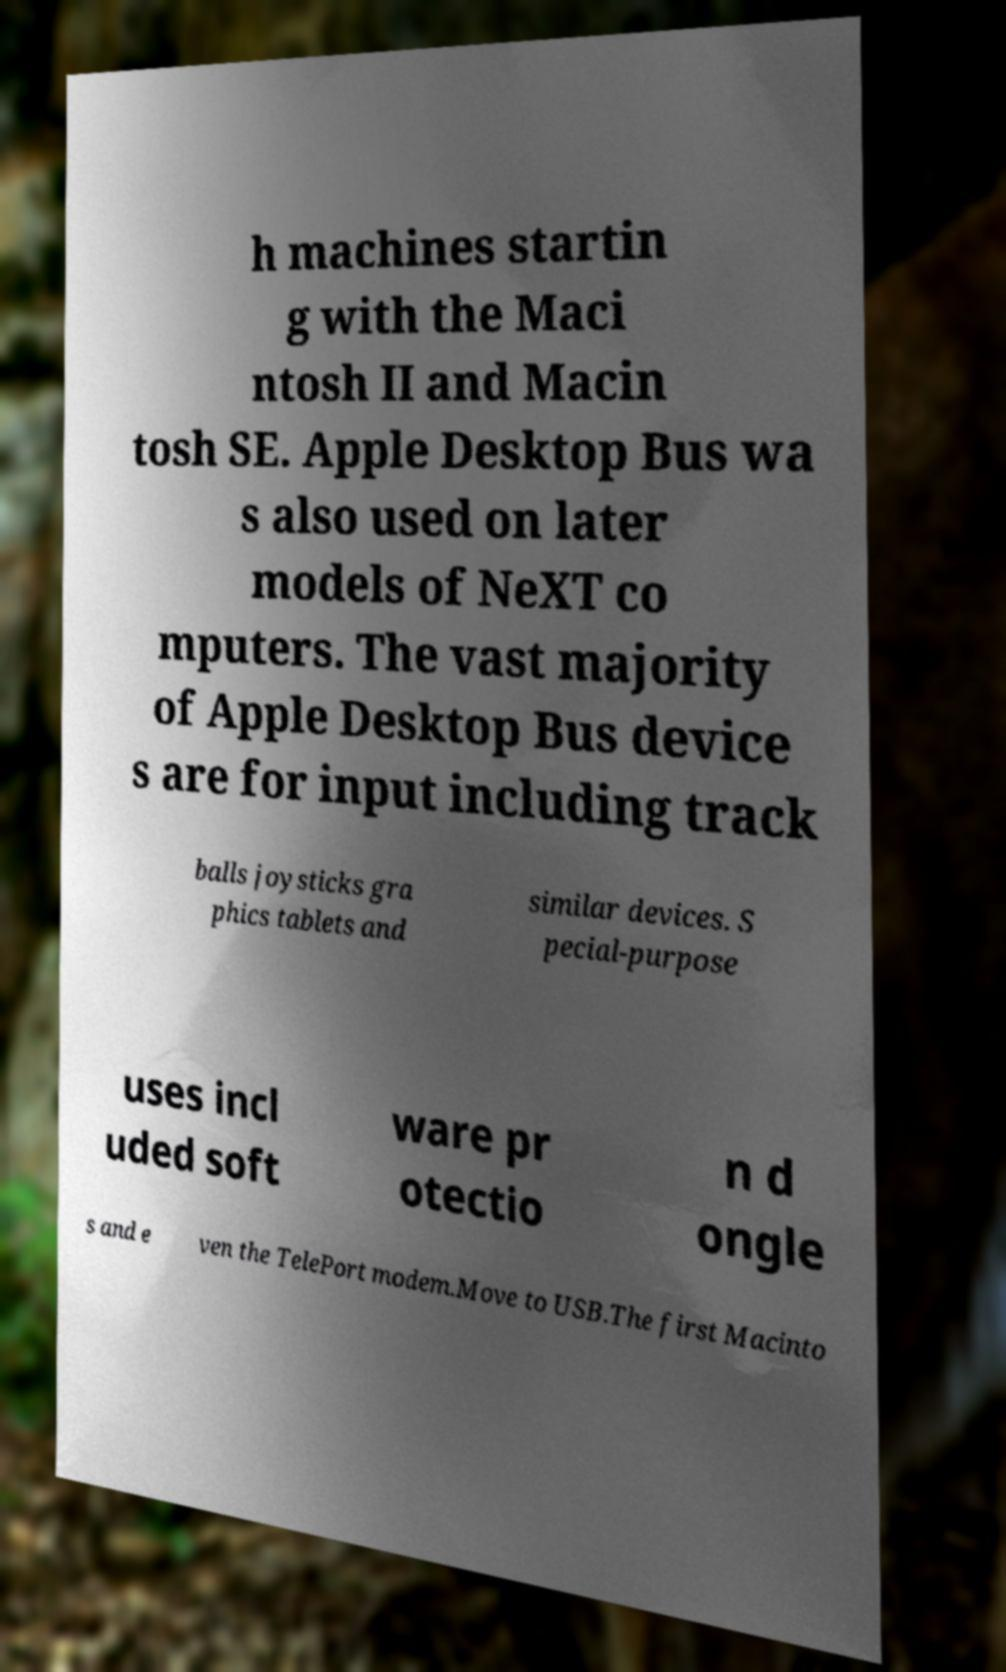Please read and relay the text visible in this image. What does it say? h machines startin g with the Maci ntosh II and Macin tosh SE. Apple Desktop Bus wa s also used on later models of NeXT co mputers. The vast majority of Apple Desktop Bus device s are for input including track balls joysticks gra phics tablets and similar devices. S pecial-purpose uses incl uded soft ware pr otectio n d ongle s and e ven the TelePort modem.Move to USB.The first Macinto 